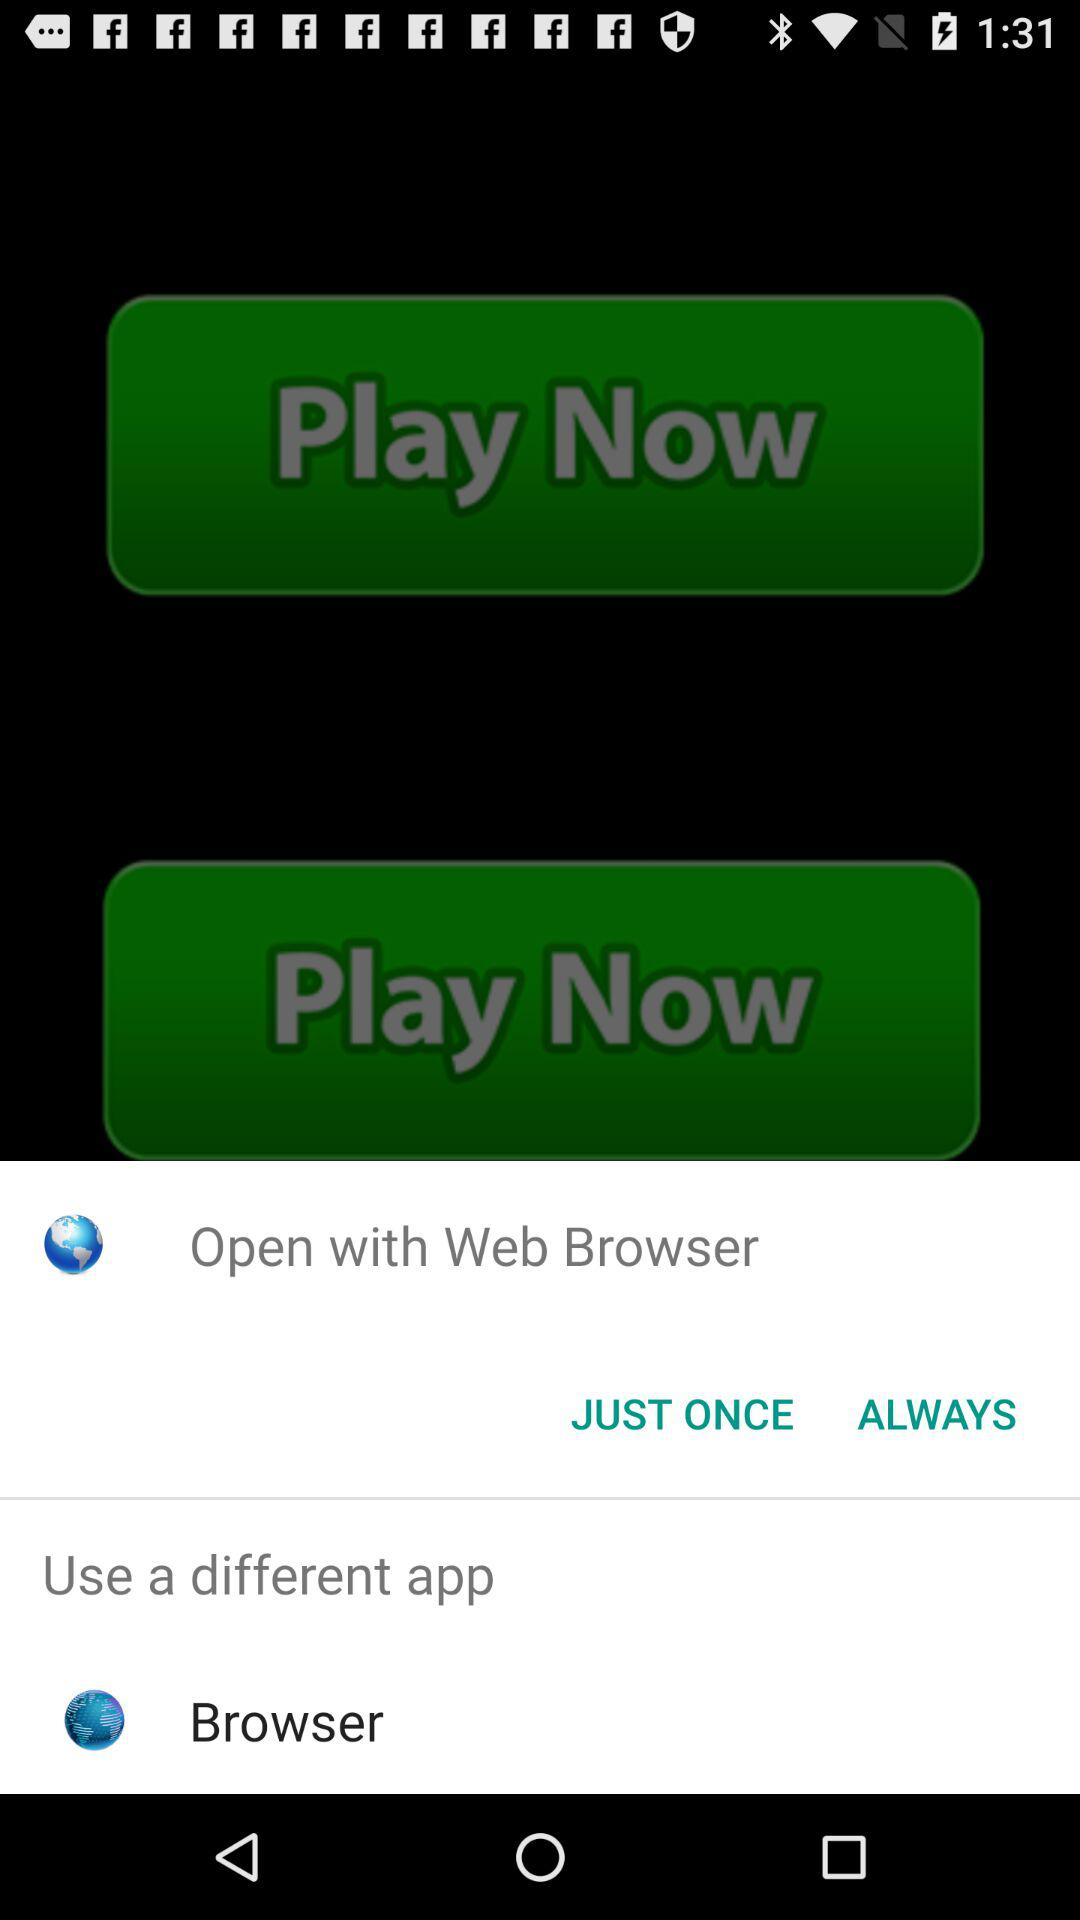What application is used to open the content? You can open it with a web browser. 